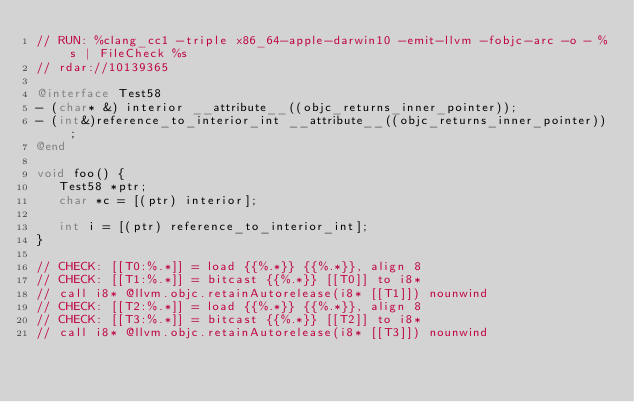<code> <loc_0><loc_0><loc_500><loc_500><_ObjectiveC_>// RUN: %clang_cc1 -triple x86_64-apple-darwin10 -emit-llvm -fobjc-arc -o - %s | FileCheck %s
// rdar://10139365

@interface Test58
- (char* &) interior __attribute__((objc_returns_inner_pointer));
- (int&)reference_to_interior_int __attribute__((objc_returns_inner_pointer));
@end

void foo() {
   Test58 *ptr;
   char *c = [(ptr) interior];

   int i = [(ptr) reference_to_interior_int];
}

// CHECK: [[T0:%.*]] = load {{%.*}} {{%.*}}, align 8
// CHECK: [[T1:%.*]] = bitcast {{%.*}} [[T0]] to i8*
// call i8* @llvm.objc.retainAutorelease(i8* [[T1]]) nounwind
// CHECK: [[T2:%.*]] = load {{%.*}} {{%.*}}, align 8
// CHECK: [[T3:%.*]] = bitcast {{%.*}} [[T2]] to i8*
// call i8* @llvm.objc.retainAutorelease(i8* [[T3]]) nounwind

</code> 